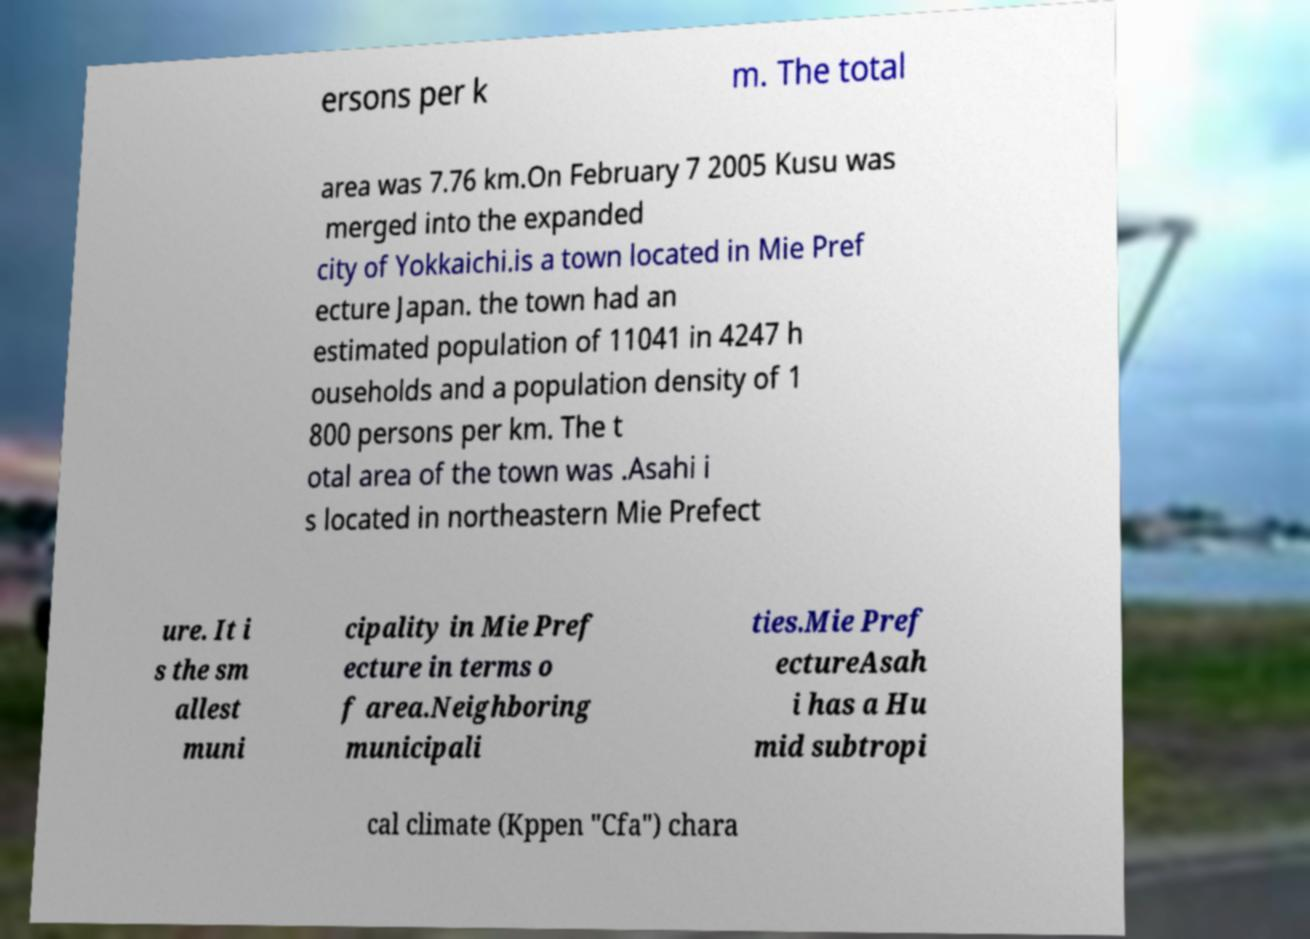What messages or text are displayed in this image? I need them in a readable, typed format. ersons per k m. The total area was 7.76 km.On February 7 2005 Kusu was merged into the expanded city of Yokkaichi.is a town located in Mie Pref ecture Japan. the town had an estimated population of 11041 in 4247 h ouseholds and a population density of 1 800 persons per km. The t otal area of the town was .Asahi i s located in northeastern Mie Prefect ure. It i s the sm allest muni cipality in Mie Pref ecture in terms o f area.Neighboring municipali ties.Mie Pref ectureAsah i has a Hu mid subtropi cal climate (Kppen "Cfa") chara 